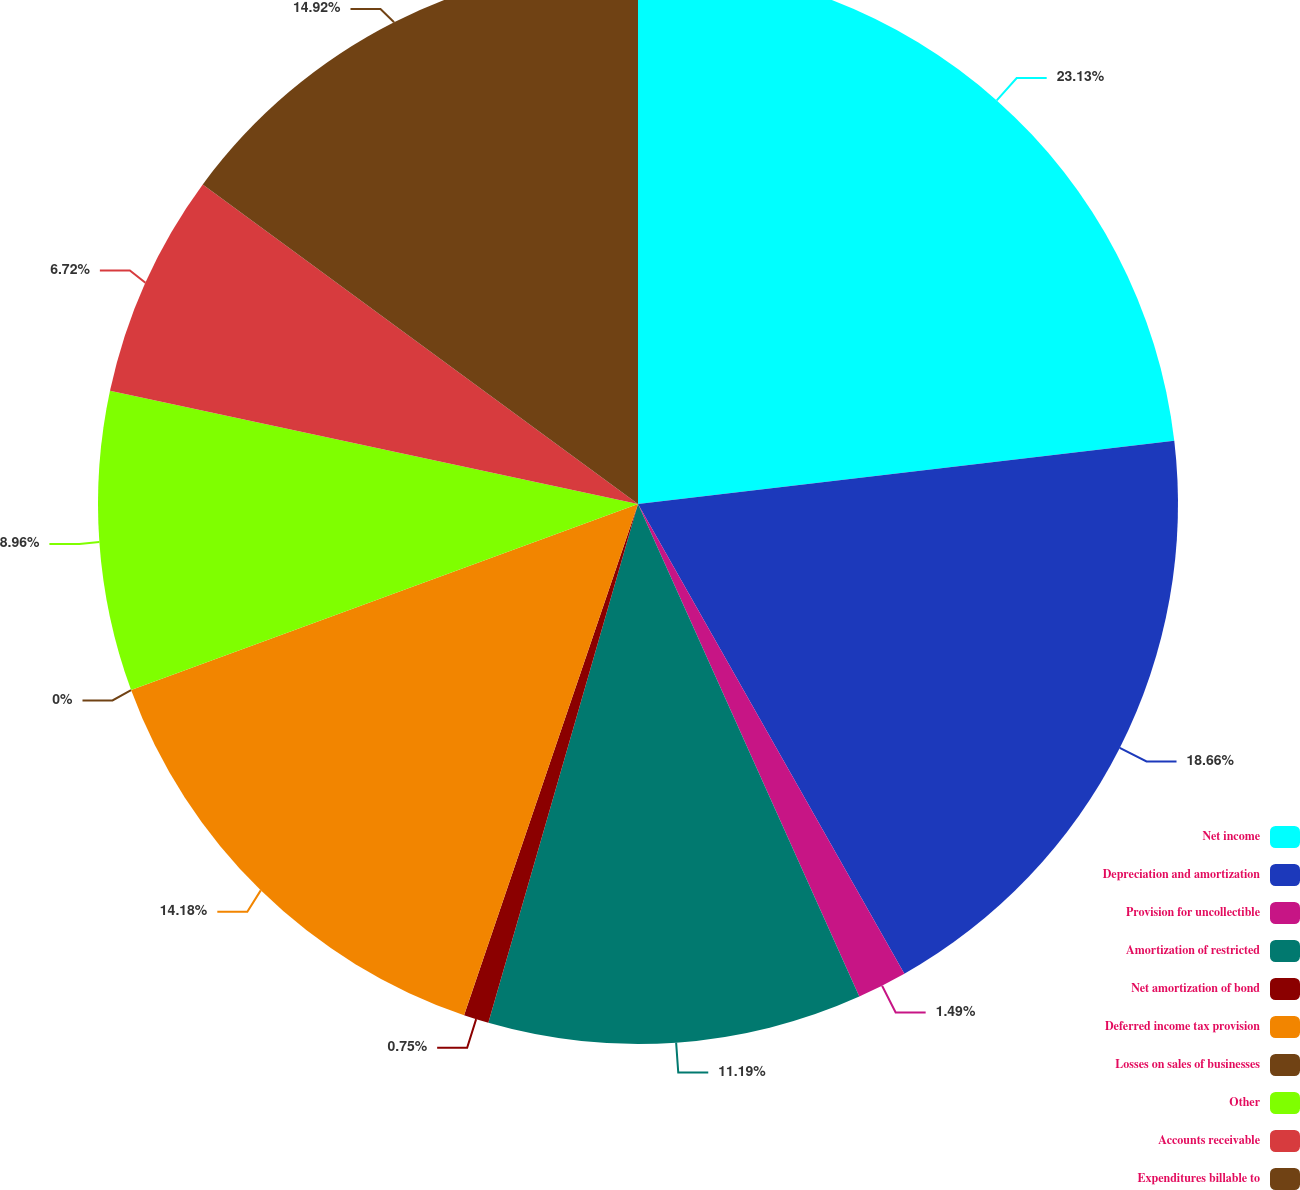<chart> <loc_0><loc_0><loc_500><loc_500><pie_chart><fcel>Net income<fcel>Depreciation and amortization<fcel>Provision for uncollectible<fcel>Amortization of restricted<fcel>Net amortization of bond<fcel>Deferred income tax provision<fcel>Losses on sales of businesses<fcel>Other<fcel>Accounts receivable<fcel>Expenditures billable to<nl><fcel>23.13%<fcel>18.66%<fcel>1.49%<fcel>11.19%<fcel>0.75%<fcel>14.18%<fcel>0.0%<fcel>8.96%<fcel>6.72%<fcel>14.92%<nl></chart> 